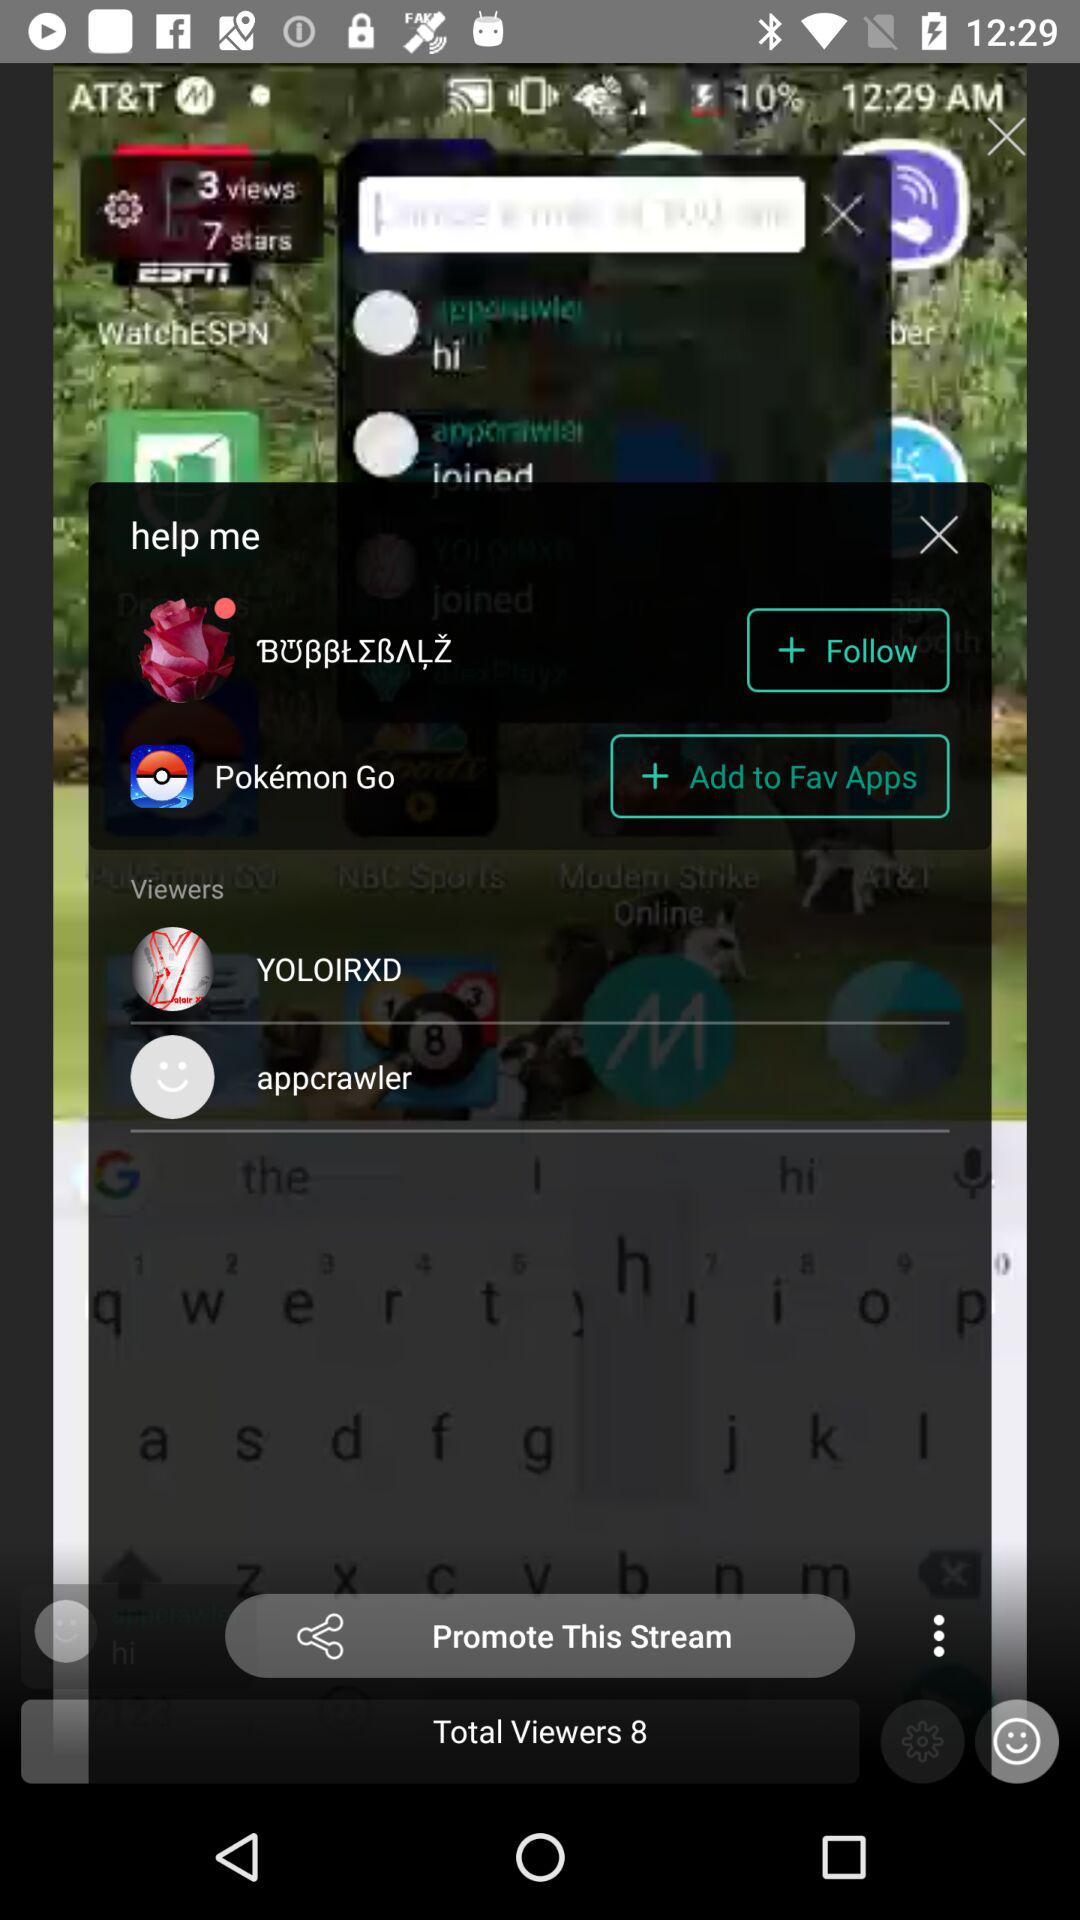How many people viewed the application? The application is viewed by 3 people. 